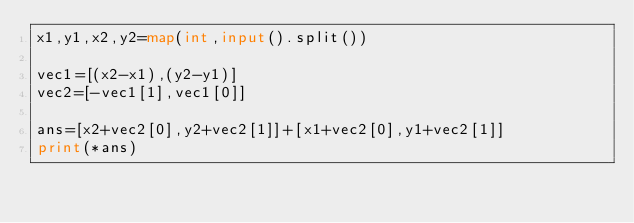<code> <loc_0><loc_0><loc_500><loc_500><_Python_>x1,y1,x2,y2=map(int,input().split())

vec1=[(x2-x1),(y2-y1)]
vec2=[-vec1[1],vec1[0]]

ans=[x2+vec2[0],y2+vec2[1]]+[x1+vec2[0],y1+vec2[1]]
print(*ans)</code> 